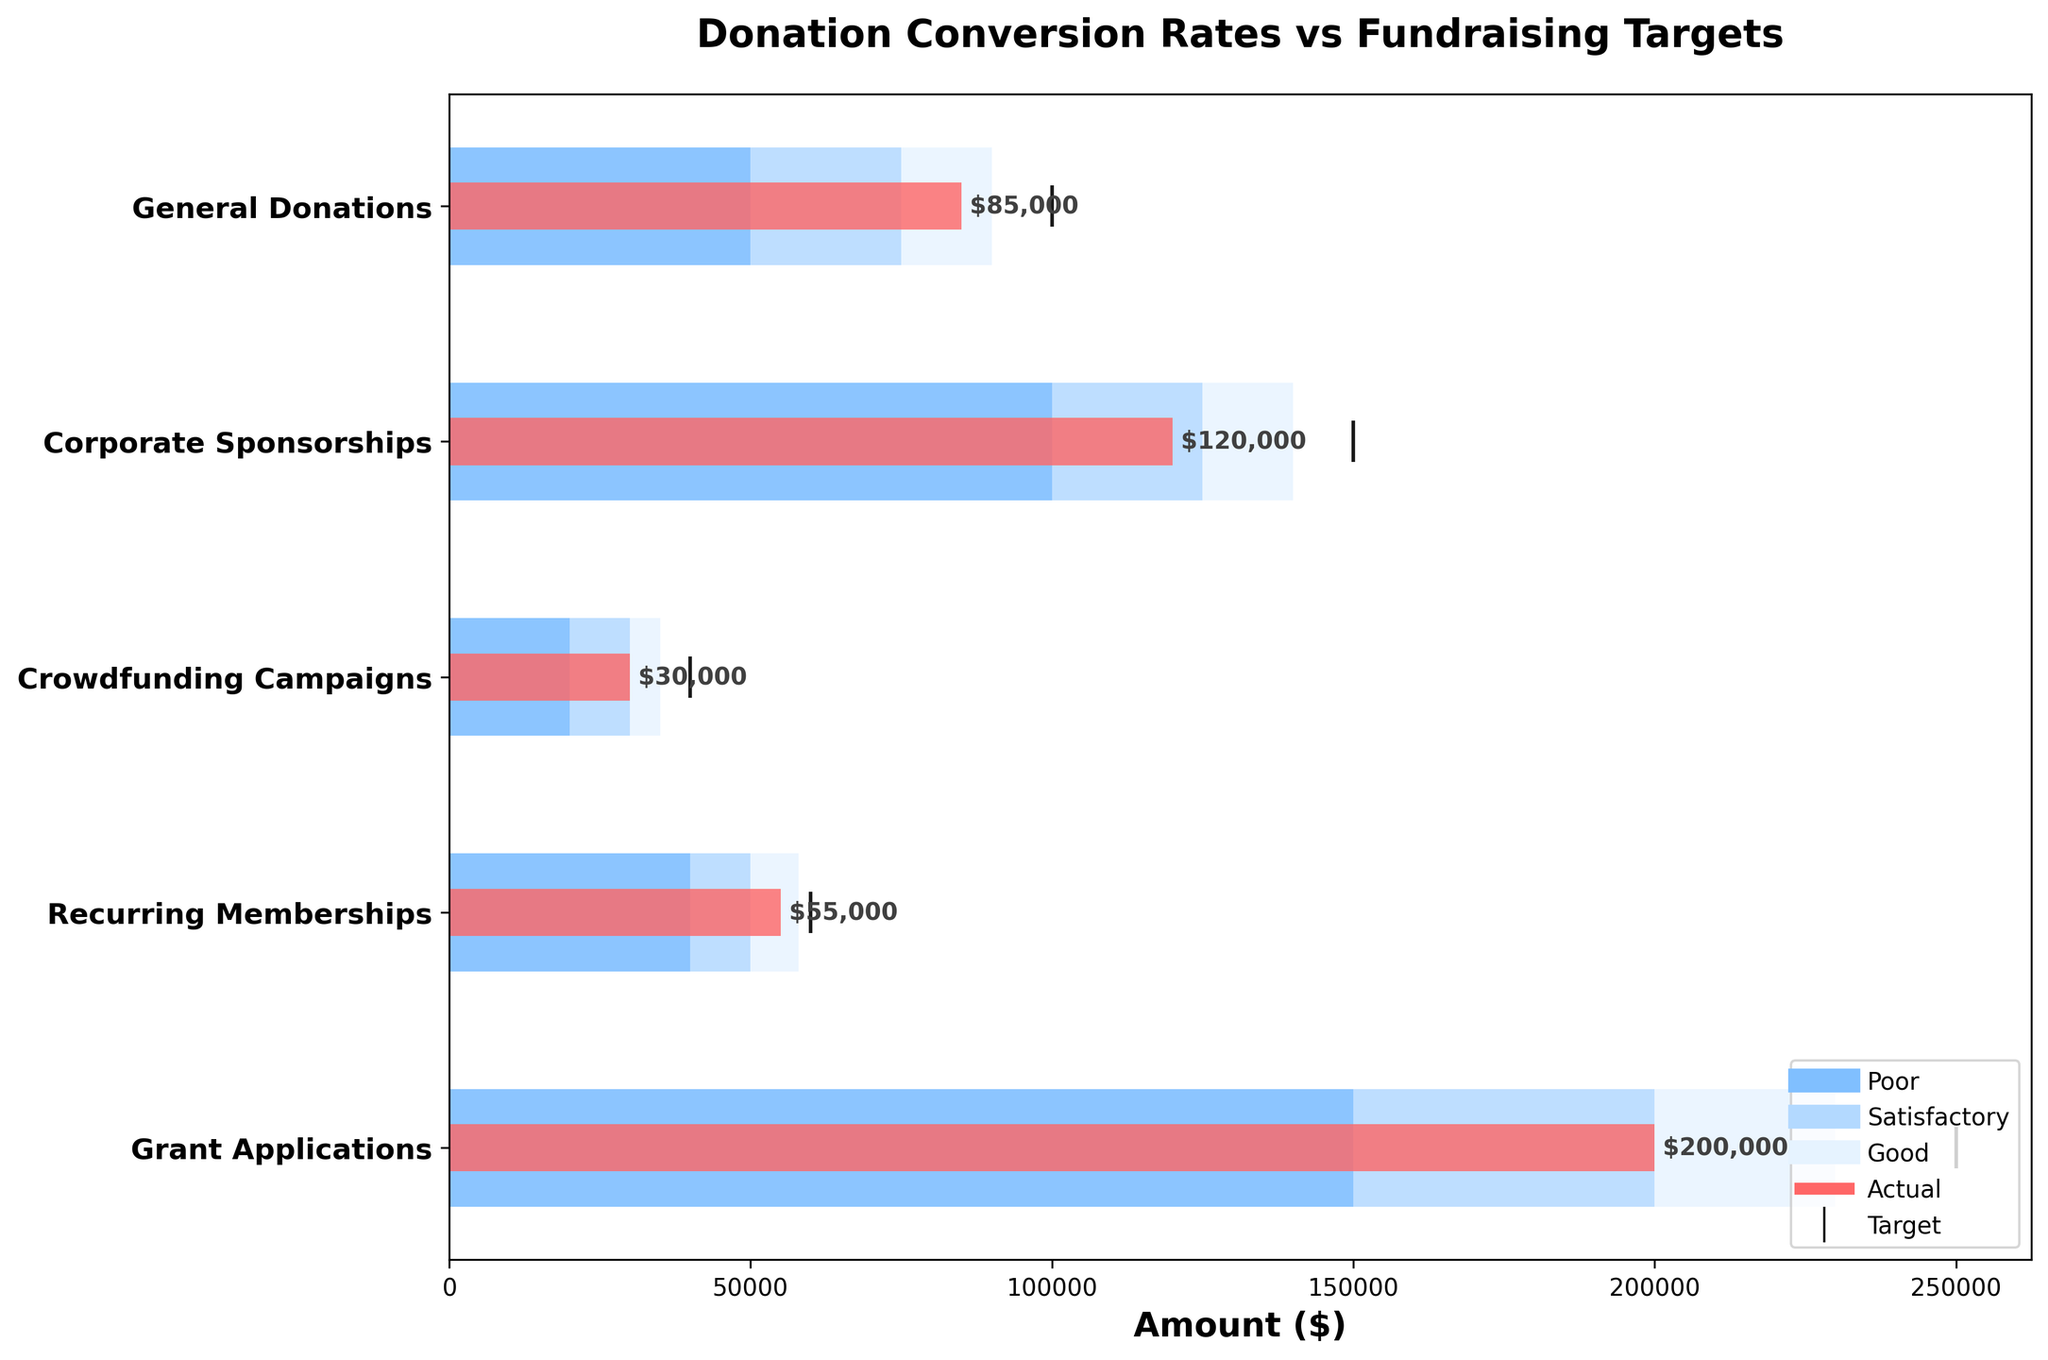What is the title of the chart? The title is located at the top-center of the chart and is written in bold text.
Answer: Donation Conversion Rates vs Fundraising Targets Which donation category has the highest actual value? To determine the highest actual value, observe the red bars in each category. The longest red bar corresponds to the highest actual value.
Answer: Grant Applications Are all categories performing above the 'Poor' benchmark level? The 'Poor' benchmark is visualized as the darkest blue section of each bar. All categories have their red bars extending beyond this section.
Answer: Yes What is the difference between the actual and target values for Corporate Sponsorships? The actual value for Corporate Sponsorships is 120,000, and the target value is 150,000. The difference is calculated as 150,000 - 120,000.
Answer: 30,000 Which category is closest to meeting its target? This is determined by comparing the proximity of the red bars to the target markers (vertical lines) for each category. Recurring Memberships' red bar is closest to its black target marker.
Answer: Recurring Memberships For which category is the actual value significantly higher than the 'Good' benchmark level? Compare the length of the red bar with the lightest blue section for each category. The actual value for Grant Applications is highest above the 'Good' level.
Answer: Grant Applications How many categories have actual values exceeding the 'Satisfactory' benchmark but not reaching the 'Good' benchmark? Analyze each category to see if the red bar extends past the medium blue section but is within the lightest blue section. There are three such categories: General Donations, Crowdfunding Campaigns, and Recurring Memberships.
Answer: Three What's the total actual value combined across all categories? Sum the actual values across all categories: 85,000 (General Donations) + 120,000 (Corporate Sponsorships) + 30,000 (Crowdfunding Campaigns) + 55,000 (Recurring Memberships) + 200,000 (Grant Applications).
Answer: 490,000 In which categories are the target values not met? Compare the actual values (red bars) and target markers (vertical lines) for each category. The categories with red bars visibly shorter than the target markers are General Donations, Corporate Sponsorships, Crowdfunding Campaigns, and Recurring Memberships.
Answer: Four 